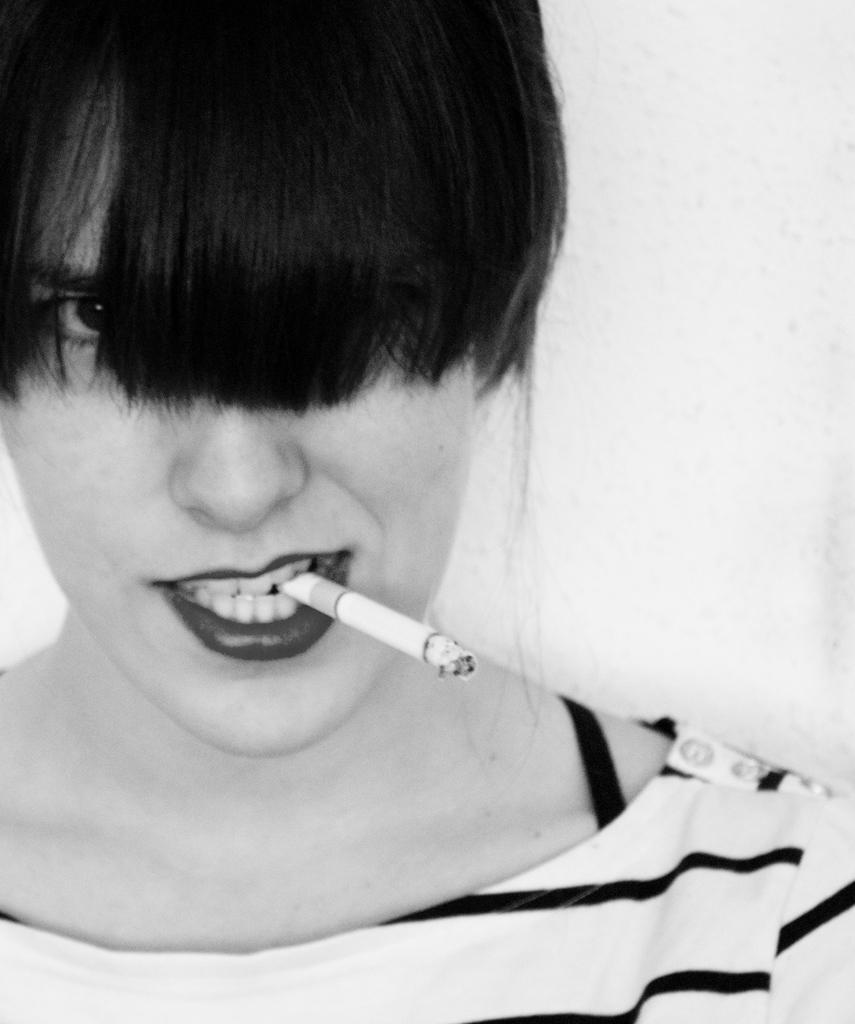Can you describe this image briefly? In this image we can see a lady where her eyes are covered with her hair and a lighted cigarette is there in her mouth. 